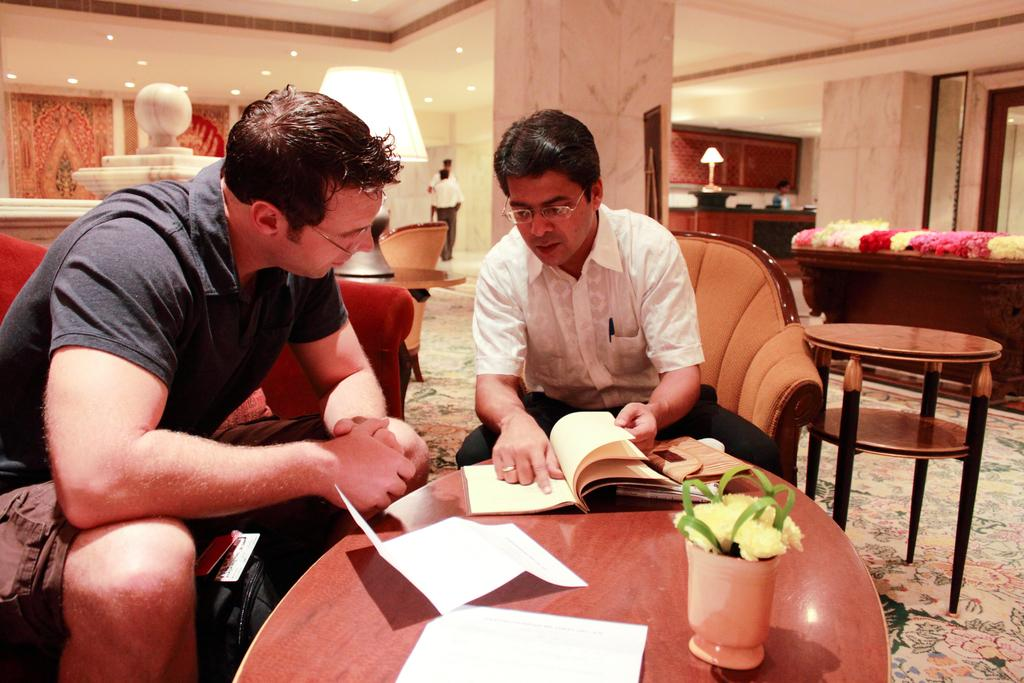How many people are in the image? There are two persons in the image. What are the persons doing in the image? The persons are sitting on chairs and holding a book. What is located on the table in the image? There is a table in the image, and on it, there are papers, a flower pot, and a lamp. Can you see a twig being used as a bookmark in the image? There is no twig present in the image, and it is not being used as a bookmark. What is the persons' attempt to balance the lamp on the flower pot in the image? There is no attempt to balance the lamp on the flower pot in the image; the lamp is separate from the flower pot. 